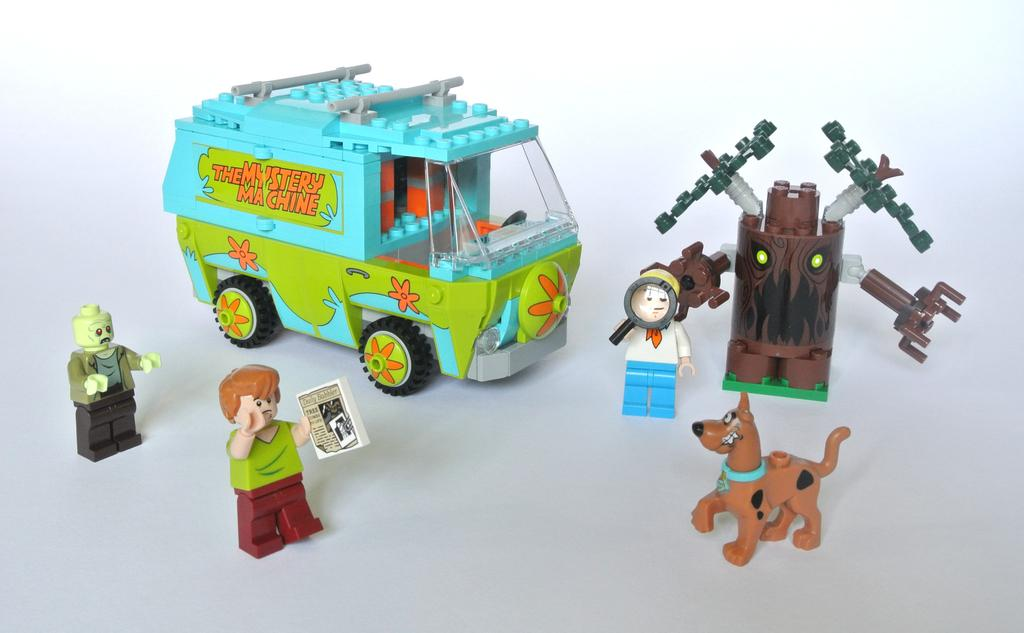What types of toys are present in the image? There are toys of 3 people, a toy dog, a robotic tree toy, and a toy vehicle in the image. What is the color of the background in the image? The background of the image is white. What team is the kitty playing for in the image? There is no kitty present in the image. 